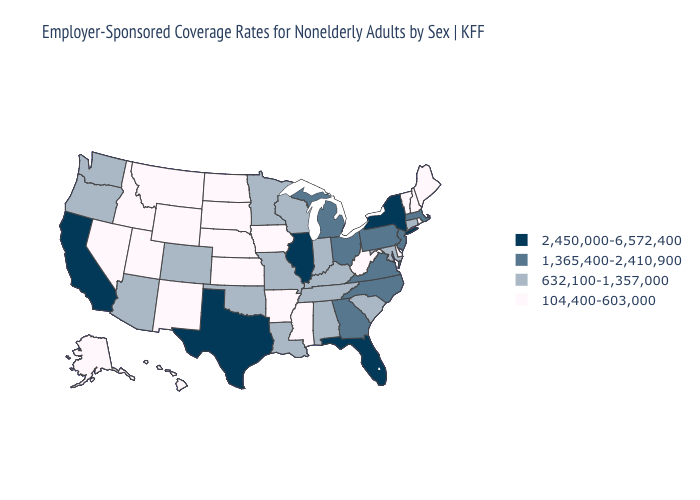Name the states that have a value in the range 2,450,000-6,572,400?
Keep it brief. California, Florida, Illinois, New York, Texas. What is the value of Illinois?
Write a very short answer. 2,450,000-6,572,400. Does Maine have the lowest value in the Northeast?
Give a very brief answer. Yes. Which states have the lowest value in the USA?
Quick response, please. Alaska, Arkansas, Delaware, Hawaii, Idaho, Iowa, Kansas, Maine, Mississippi, Montana, Nebraska, Nevada, New Hampshire, New Mexico, North Dakota, Rhode Island, South Dakota, Utah, Vermont, West Virginia, Wyoming. Does Alabama have the same value as Idaho?
Write a very short answer. No. What is the value of New Jersey?
Short answer required. 1,365,400-2,410,900. What is the value of Rhode Island?
Keep it brief. 104,400-603,000. Among the states that border Nevada , does California have the highest value?
Concise answer only. Yes. Does the map have missing data?
Concise answer only. No. Does Massachusetts have the highest value in the USA?
Answer briefly. No. What is the lowest value in states that border New York?
Keep it brief. 104,400-603,000. Does Mississippi have the same value as West Virginia?
Keep it brief. Yes. How many symbols are there in the legend?
Answer briefly. 4. Among the states that border Utah , which have the lowest value?
Answer briefly. Idaho, Nevada, New Mexico, Wyoming. Name the states that have a value in the range 1,365,400-2,410,900?
Concise answer only. Georgia, Massachusetts, Michigan, New Jersey, North Carolina, Ohio, Pennsylvania, Virginia. 